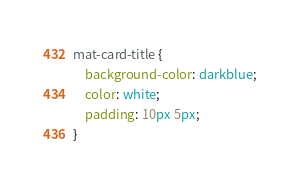Convert code to text. <code><loc_0><loc_0><loc_500><loc_500><_CSS_>mat-card-title {
    background-color: darkblue;
    color: white;
    padding: 10px 5px;
}</code> 